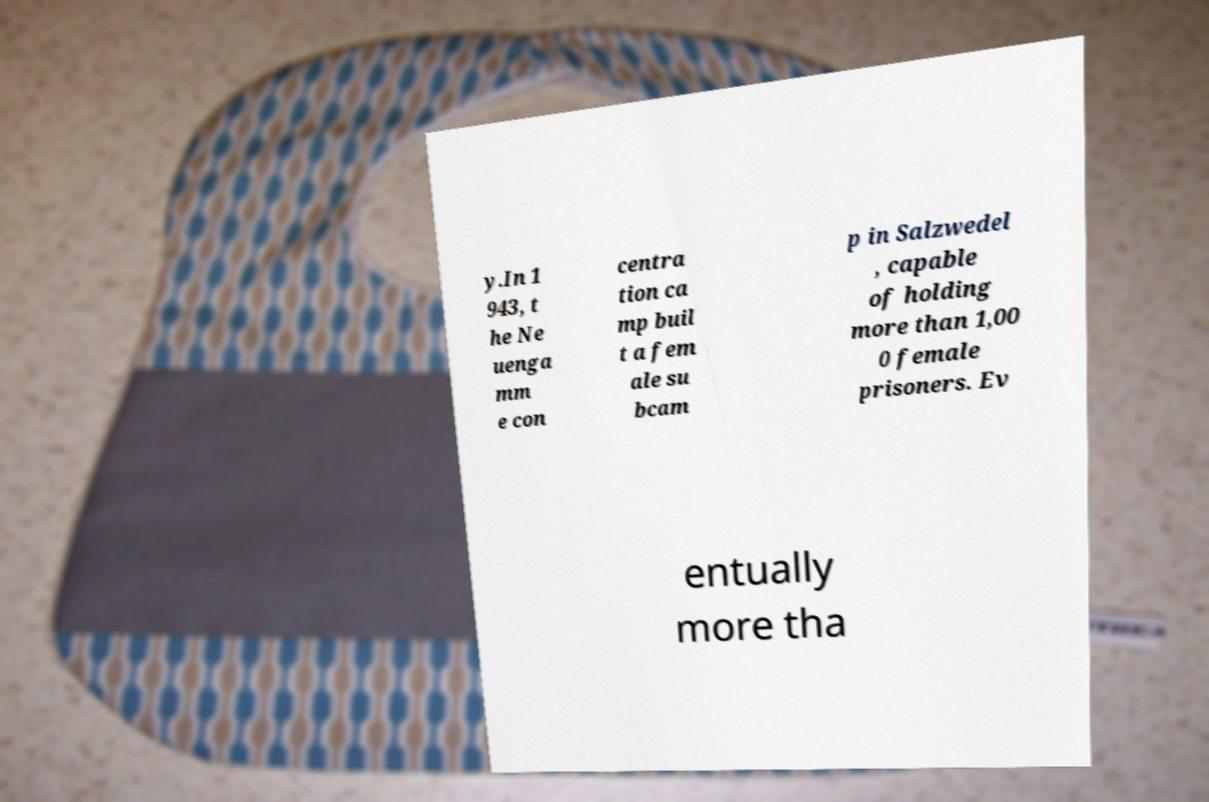Please read and relay the text visible in this image. What does it say? y.In 1 943, t he Ne uenga mm e con centra tion ca mp buil t a fem ale su bcam p in Salzwedel , capable of holding more than 1,00 0 female prisoners. Ev entually more tha 